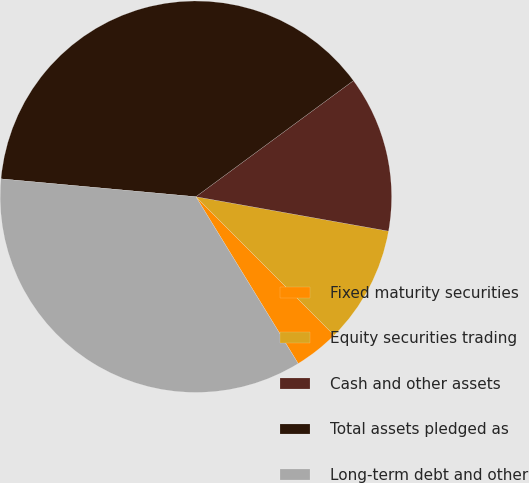Convert chart. <chart><loc_0><loc_0><loc_500><loc_500><pie_chart><fcel>Fixed maturity securities<fcel>Equity securities trading<fcel>Cash and other assets<fcel>Total assets pledged as<fcel>Long-term debt and other<nl><fcel>3.73%<fcel>9.7%<fcel>12.92%<fcel>38.44%<fcel>35.21%<nl></chart> 